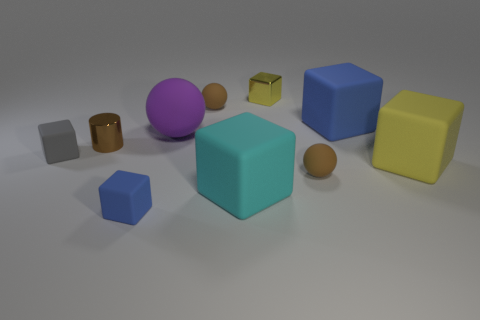How would you describe the atmosphere or mood this image conveys? The atmosphere of the image is quite neutral and tranquil, devoid of any intense emotion. The soft diffuse lighting creates a calm setting, while the simple geometry and muted colors of the objects give off a minimalistic and perhaps educational vibe, reminiscent of a learning environment for children or a simulation space. 